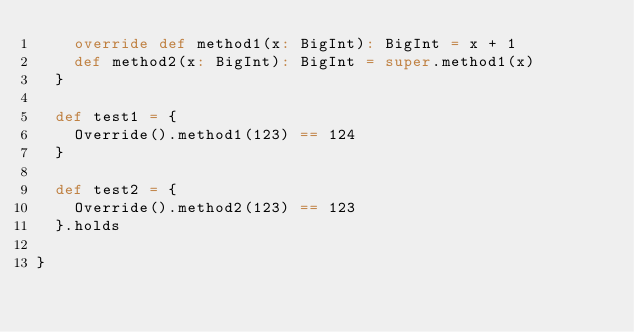Convert code to text. <code><loc_0><loc_0><loc_500><loc_500><_Scala_>    override def method1(x: BigInt): BigInt = x + 1
    def method2(x: BigInt): BigInt = super.method1(x)
  }

  def test1 = {
    Override().method1(123) == 124
  }

  def test2 = {
    Override().method2(123) == 123
  }.holds

}
</code> 